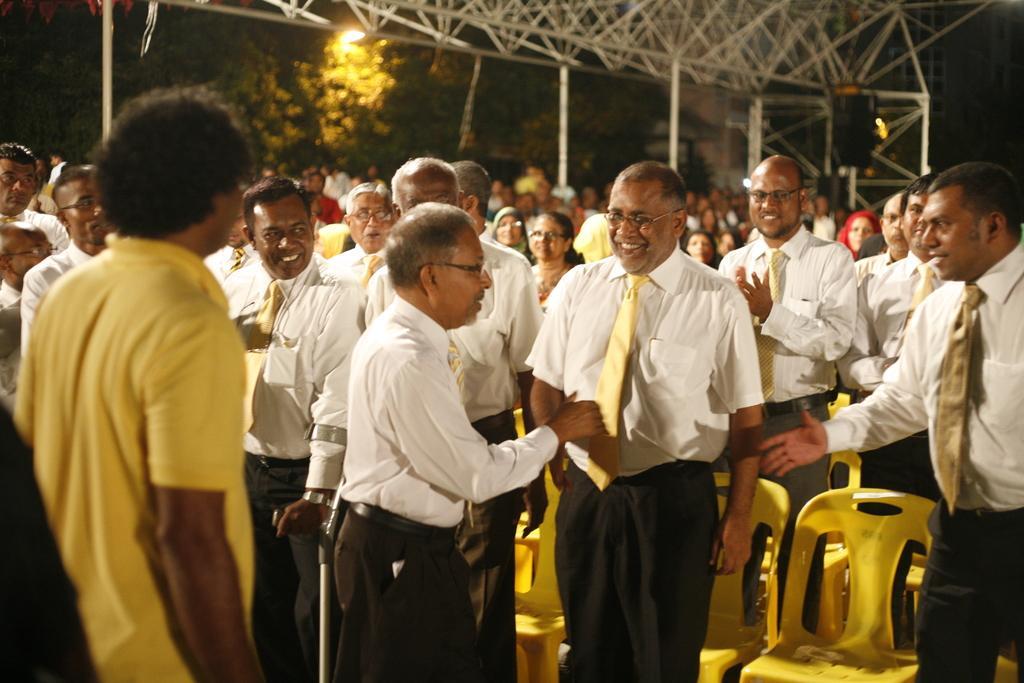Could you give a brief overview of what you see in this image? In this image we can see people standing on the floor. In the background there are chairs, grills, trees and sky. 